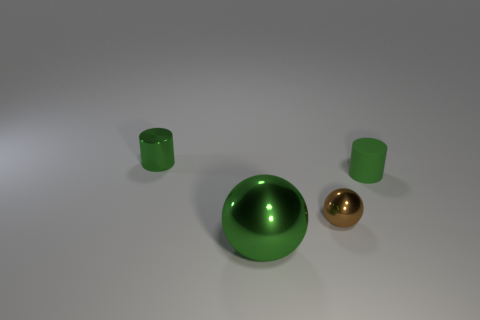What number of things are cylinders that are right of the small green shiny cylinder or metallic things on the left side of the small brown metal object?
Your response must be concise. 3. How many tiny green things have the same shape as the brown shiny thing?
Your answer should be very brief. 0. There is a tiny object that is both behind the small brown ball and to the left of the rubber cylinder; what is its material?
Your response must be concise. Metal. What number of tiny things are in front of the small green shiny cylinder?
Offer a very short reply. 2. What number of matte objects are there?
Give a very brief answer. 1. Is the brown sphere the same size as the green rubber cylinder?
Provide a short and direct response. Yes. Is there a big green metal sphere left of the large metallic ball to the right of the tiny object that is behind the matte cylinder?
Offer a very short reply. No. What material is the small brown thing that is the same shape as the large metallic object?
Offer a very short reply. Metal. There is a tiny shiny thing in front of the matte thing; what color is it?
Offer a terse response. Brown. What size is the green metallic ball?
Your answer should be compact. Large. 